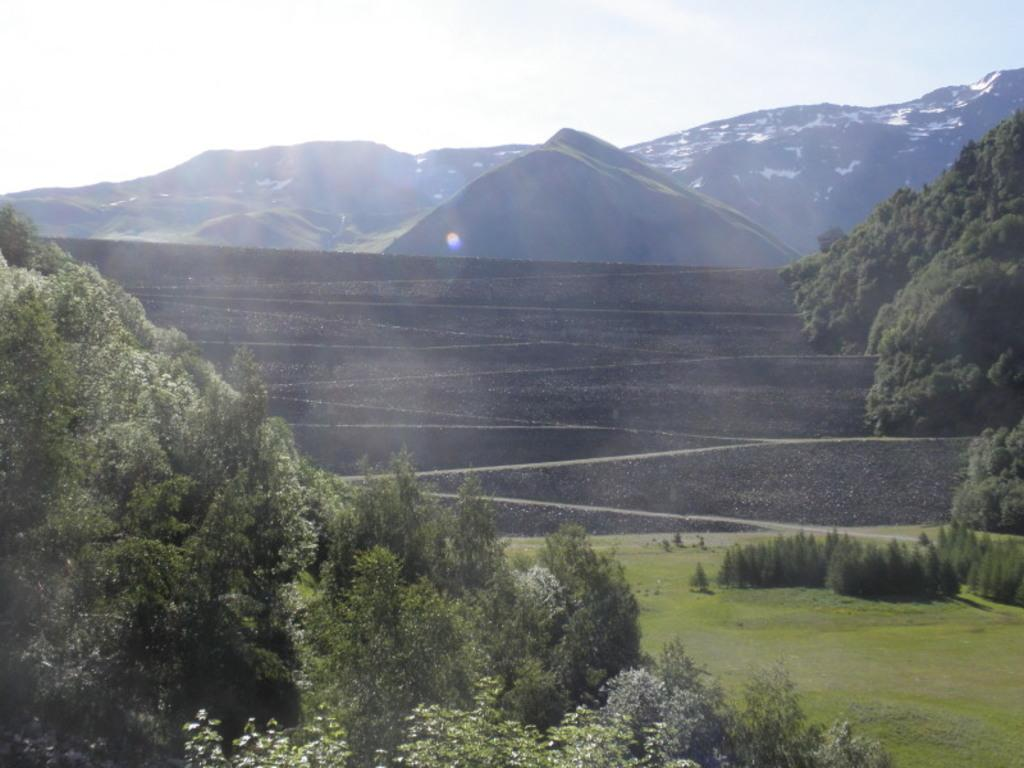What type of scenery is shown in the image? The image depicts a beautiful scenery. What type of vegetation is present in the image? There is grass in the image. What can be seen in the background of the image? There are trees and beautiful mountains visible in the background of the image. What grade does the root of the tree receive in the image? There is no grading system or root of a tree present in the image. How does the image show the process of photosynthesis? The image does not show the process of photosynthesis; it simply depicts a beautiful scenery with grass, trees, and mountains. 